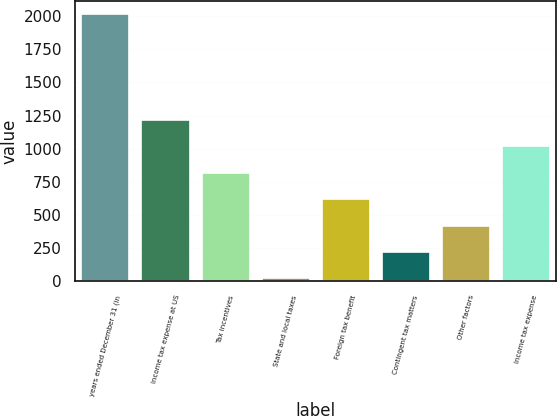<chart> <loc_0><loc_0><loc_500><loc_500><bar_chart><fcel>years ended December 31 (in<fcel>Income tax expense at US<fcel>Tax incentives<fcel>State and local taxes<fcel>Foreign tax benefit<fcel>Contingent tax matters<fcel>Other factors<fcel>Income tax expense<nl><fcel>2013<fcel>1216.6<fcel>818.4<fcel>22<fcel>619.3<fcel>221.1<fcel>420.2<fcel>1017.5<nl></chart> 